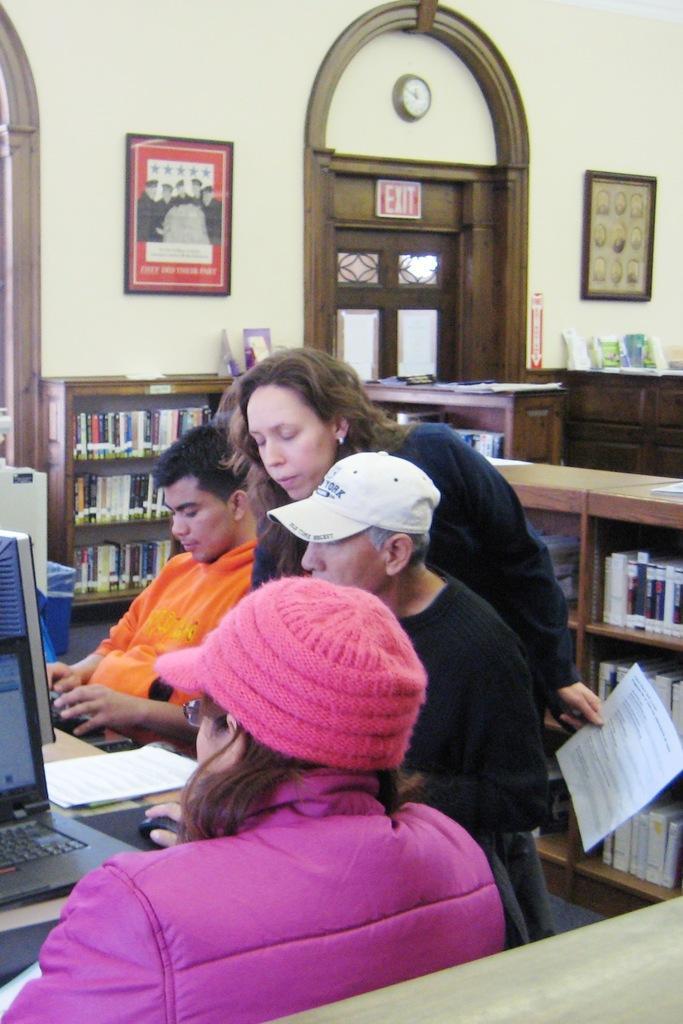Describe this image in one or two sentences. In this image there are a few people sitting and standing, one of them is holding papers in her hand, in front of them there is a table with monitor, laptop, mouse, mouse pad and a few other objects on top of it, behind them there are so many racks stored with books and there are few objects on it. In the background there are doors and few frames are hanging on the wall. 